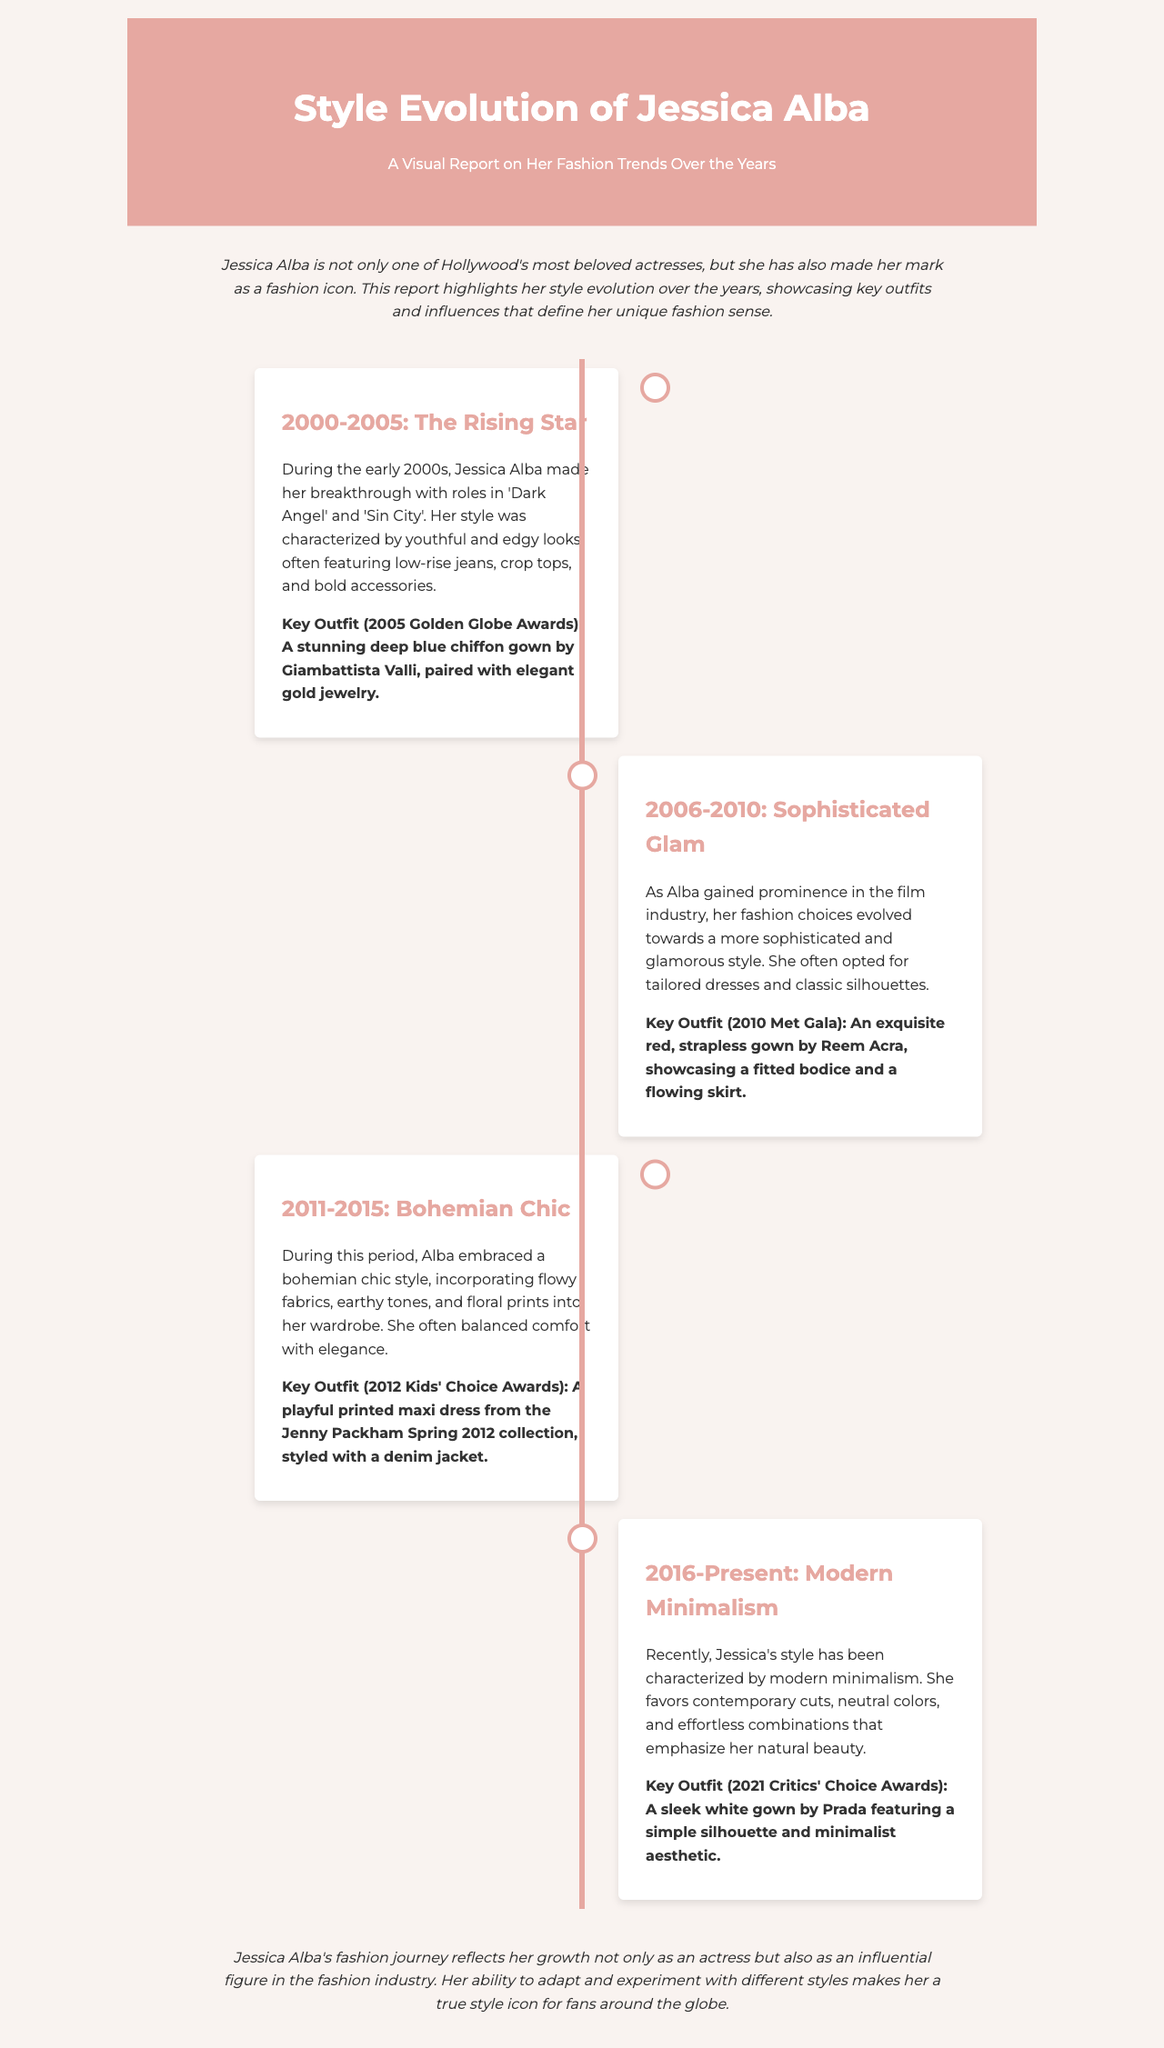What was Jessica Alba's key outfit at the 2005 Golden Globe Awards? The document identifies a stunning deep blue chiffon gown by Giambattista Valli as her key outfit for that event.
Answer: deep blue chiffon gown by Giambattista Valli What style characterized Jessica Alba during 2006-2010? The report describes her style in this period as more sophisticated and glamorous, favoring tailored dresses and classic silhouettes.
Answer: Sophisticated Glam Which designer created Jessica Alba's key outfit for the 2010 Met Gala? The document specifies that Alba's key outfit for the 2010 Met Gala was an exquisite red gown by Reem Acra.
Answer: Reem Acra How did Jessica Alba's style evolve from 2000 to 2005? The early 2000s reflected youthful and edgy looks, often featuring low-rise jeans and crop tops, indicating a transition from casual to more sophisticated fashion.
Answer: Youthful and edgy What is the main theme of Jessica Alba's style from 2016 to the present? The document states her recent style reflects modern minimalism, which includes contemporary cuts and neutral colors.
Answer: Modern minimalism What was Jessica Alba's key outfit at the 2021 Critics' Choice Awards? According to the report, her key outfit for the 2021 Critics' Choice Awards was a sleek white gown by Prada.
Answer: sleek white gown by Prada What elements define the Bohemian Chic style that Jessica Alba embraced from 2011 to 2015? The report highlights flowy fabrics, earthy tones, and floral prints as defining features of her Bohemian Chic style during this period.
Answer: Flowy fabrics, earthy tones, floral prints What does Jessica Alba's fashion journey reflect about her career? The conclusion of the report suggests her fashion journey reflects her growth not only as an actress but as an influential figure in fashion.
Answer: Growth as an actress and fashion figure 